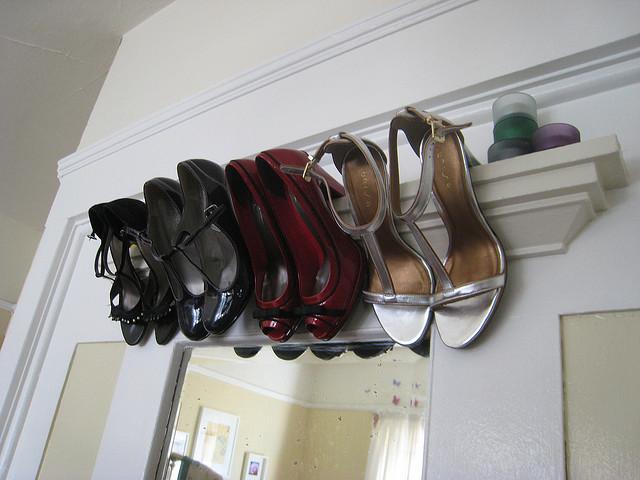Where are these shoes being stored?
Quick response, please. On shelf. How many shoes are facing down?
Answer briefly. 8. Are any of the shoes boots?
Keep it brief. No. 